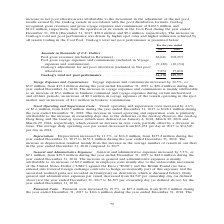From Gaslog's financial document, In which years was the total net pool performance recorded for? The document shows two values: 2018 and 2017. From the document: "For the year ended 2017 2018 For the year ended 2017 2018..." Also, What accounted for the increase in net pool allocation? Attributable to the movement in the adjustment of the net pool results earned by the GasLog vessels in accordance with the pool distribution formula.. The document states: "increase in net pool allocation was attributable to the movement in the adjustment of the net pool results earned by the GasLog vessels in accordance ..." Also, What accounted for the increase in voyage expenses and commissions? Mainly attributable to an increase of $3.6 million in bunkers consumed and voyage expenses during certain unchartered and off-hire periods, an increase of $0.3 million in voyage expenses of the vessels operating in the spot market and an increase of $1.1 million in brokers’ commissions.. The document states: "The increase in voyage expenses and commissions is mainly attributable to an increase of $3.6 million in bunkers consumed and voyage expenses during c..." Additionally, Which year was the pool gross revenues higher? According to the financial document, 2018. The relevant text states: "For the year ended 2017 2018..." Also, can you calculate: What is the change in pool gross revenues from 2017 to 2018? Based on the calculation: 102,253 - 38,046 , the result is 64207 (in thousands). This is based on the information: "ol gross revenues (included in Revenues) . 38,046 102,253 Pool gross voyage expenses and commissions (included in Voyage expenses and commissions) . (9,122) lars Pool gross revenues (included in Reven..." The key data points involved are: 102,253, 38,046. Also, can you calculate: What is the percentage change in total net pool performance from 2017 to 2018? To answer this question, I need to perform calculations using the financial data. The calculation is: (109,917 - 36,178)/36,178 , which equals 203.82 (percentage). This is based on the information: "GasLog’s total net pool performance . 36,178 109,917 GasLog’s total net pool performance . 36,178 109,917..." The key data points involved are: 109,917, 36,178. 